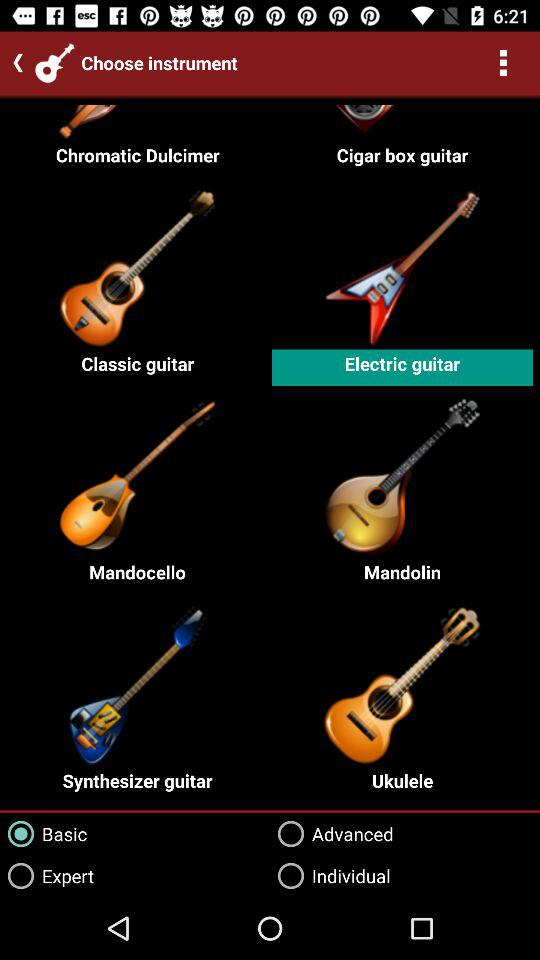Is "Advanced" selected or not? "Advanced" is not selected. 